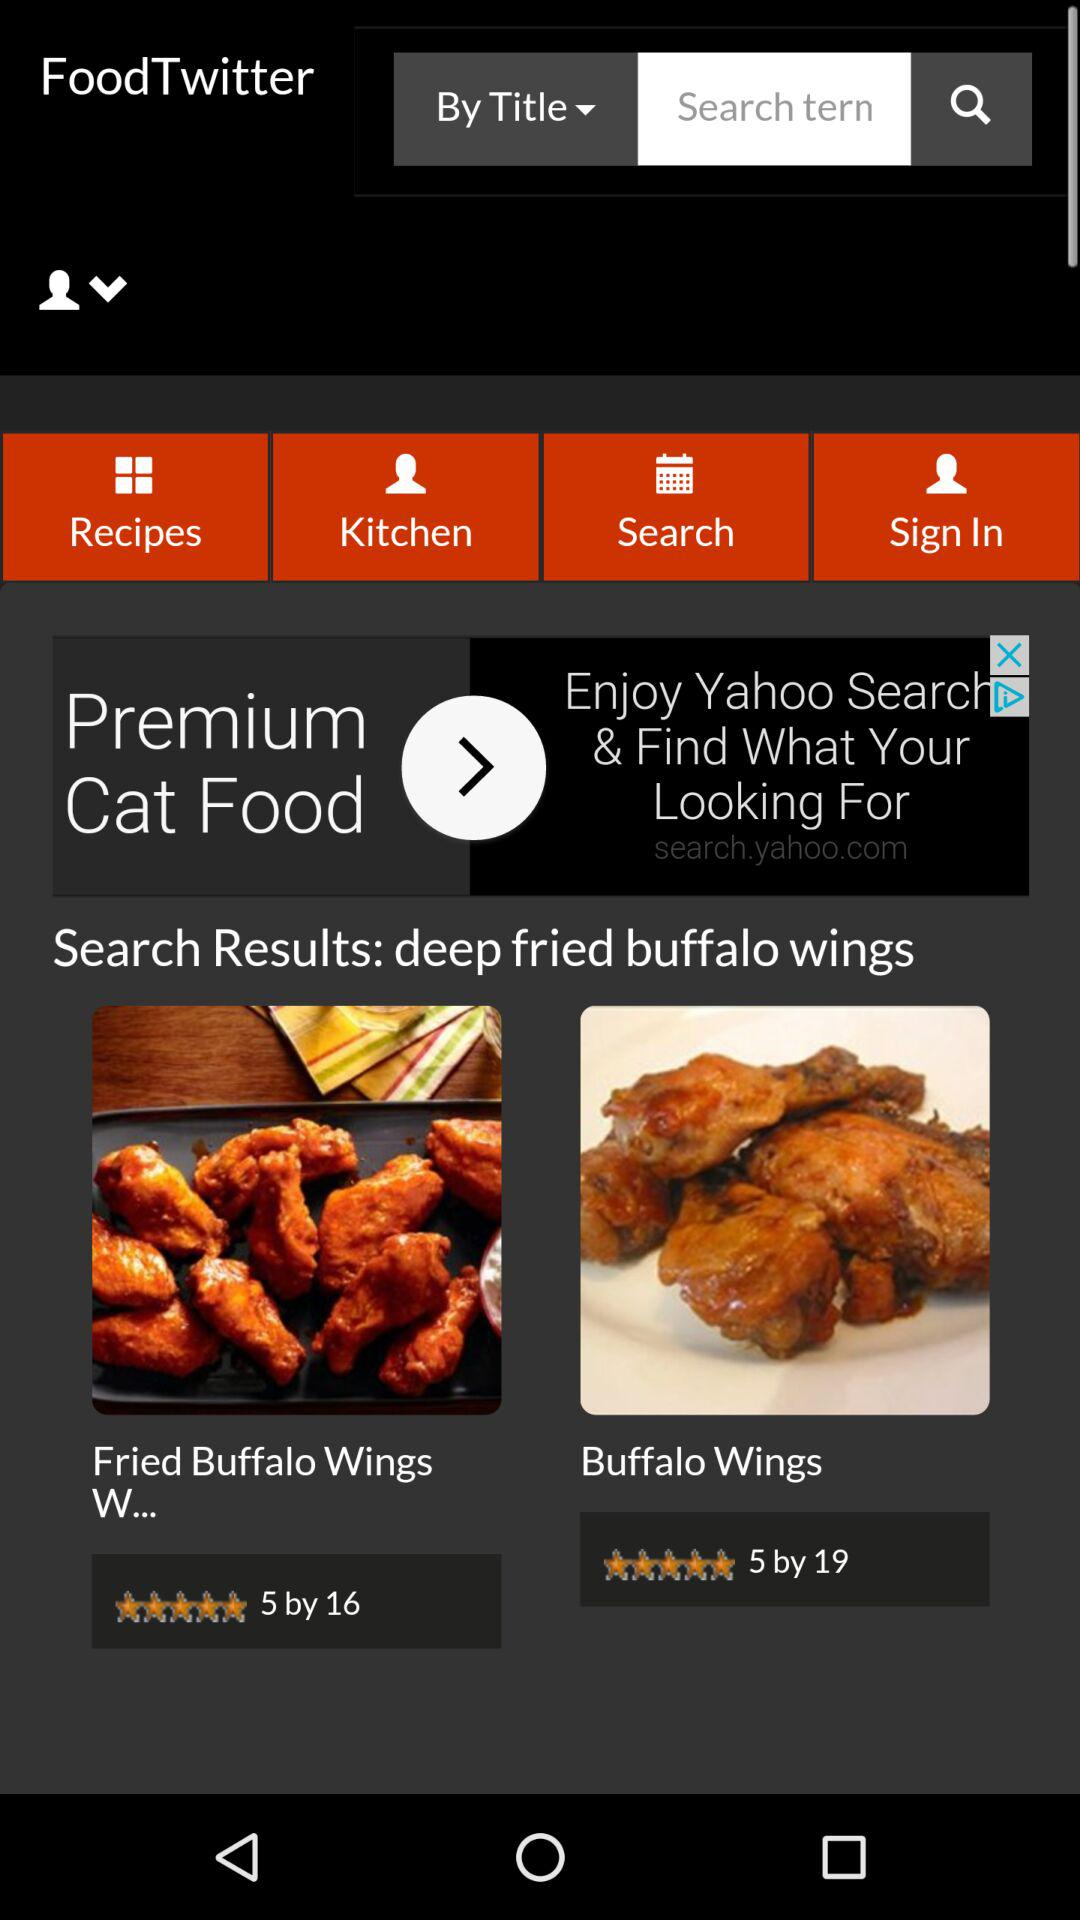What's the rating of "Buffalo Wings"? The rating is 5 stars. 